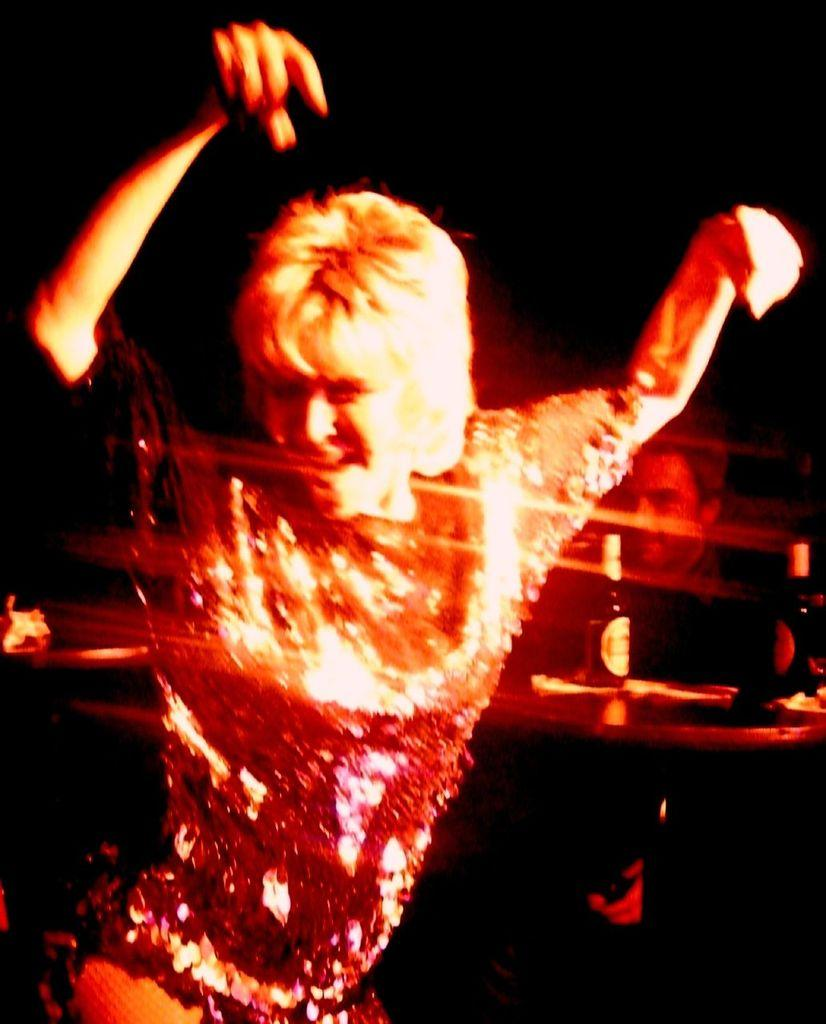What is the person in the image doing? There is a person dancing in the image. Can you describe the man on the right side of the image? There is a man on the right side of the image. What is located on the right side of the image besides the man? There is a table and bottles on the right side of the image. How would you describe the lighting in the image? The background of the image is dark. What type of shoes is the person wearing while dancing in the mist? There is no mist present in the image, and the person's shoes are not visible. 